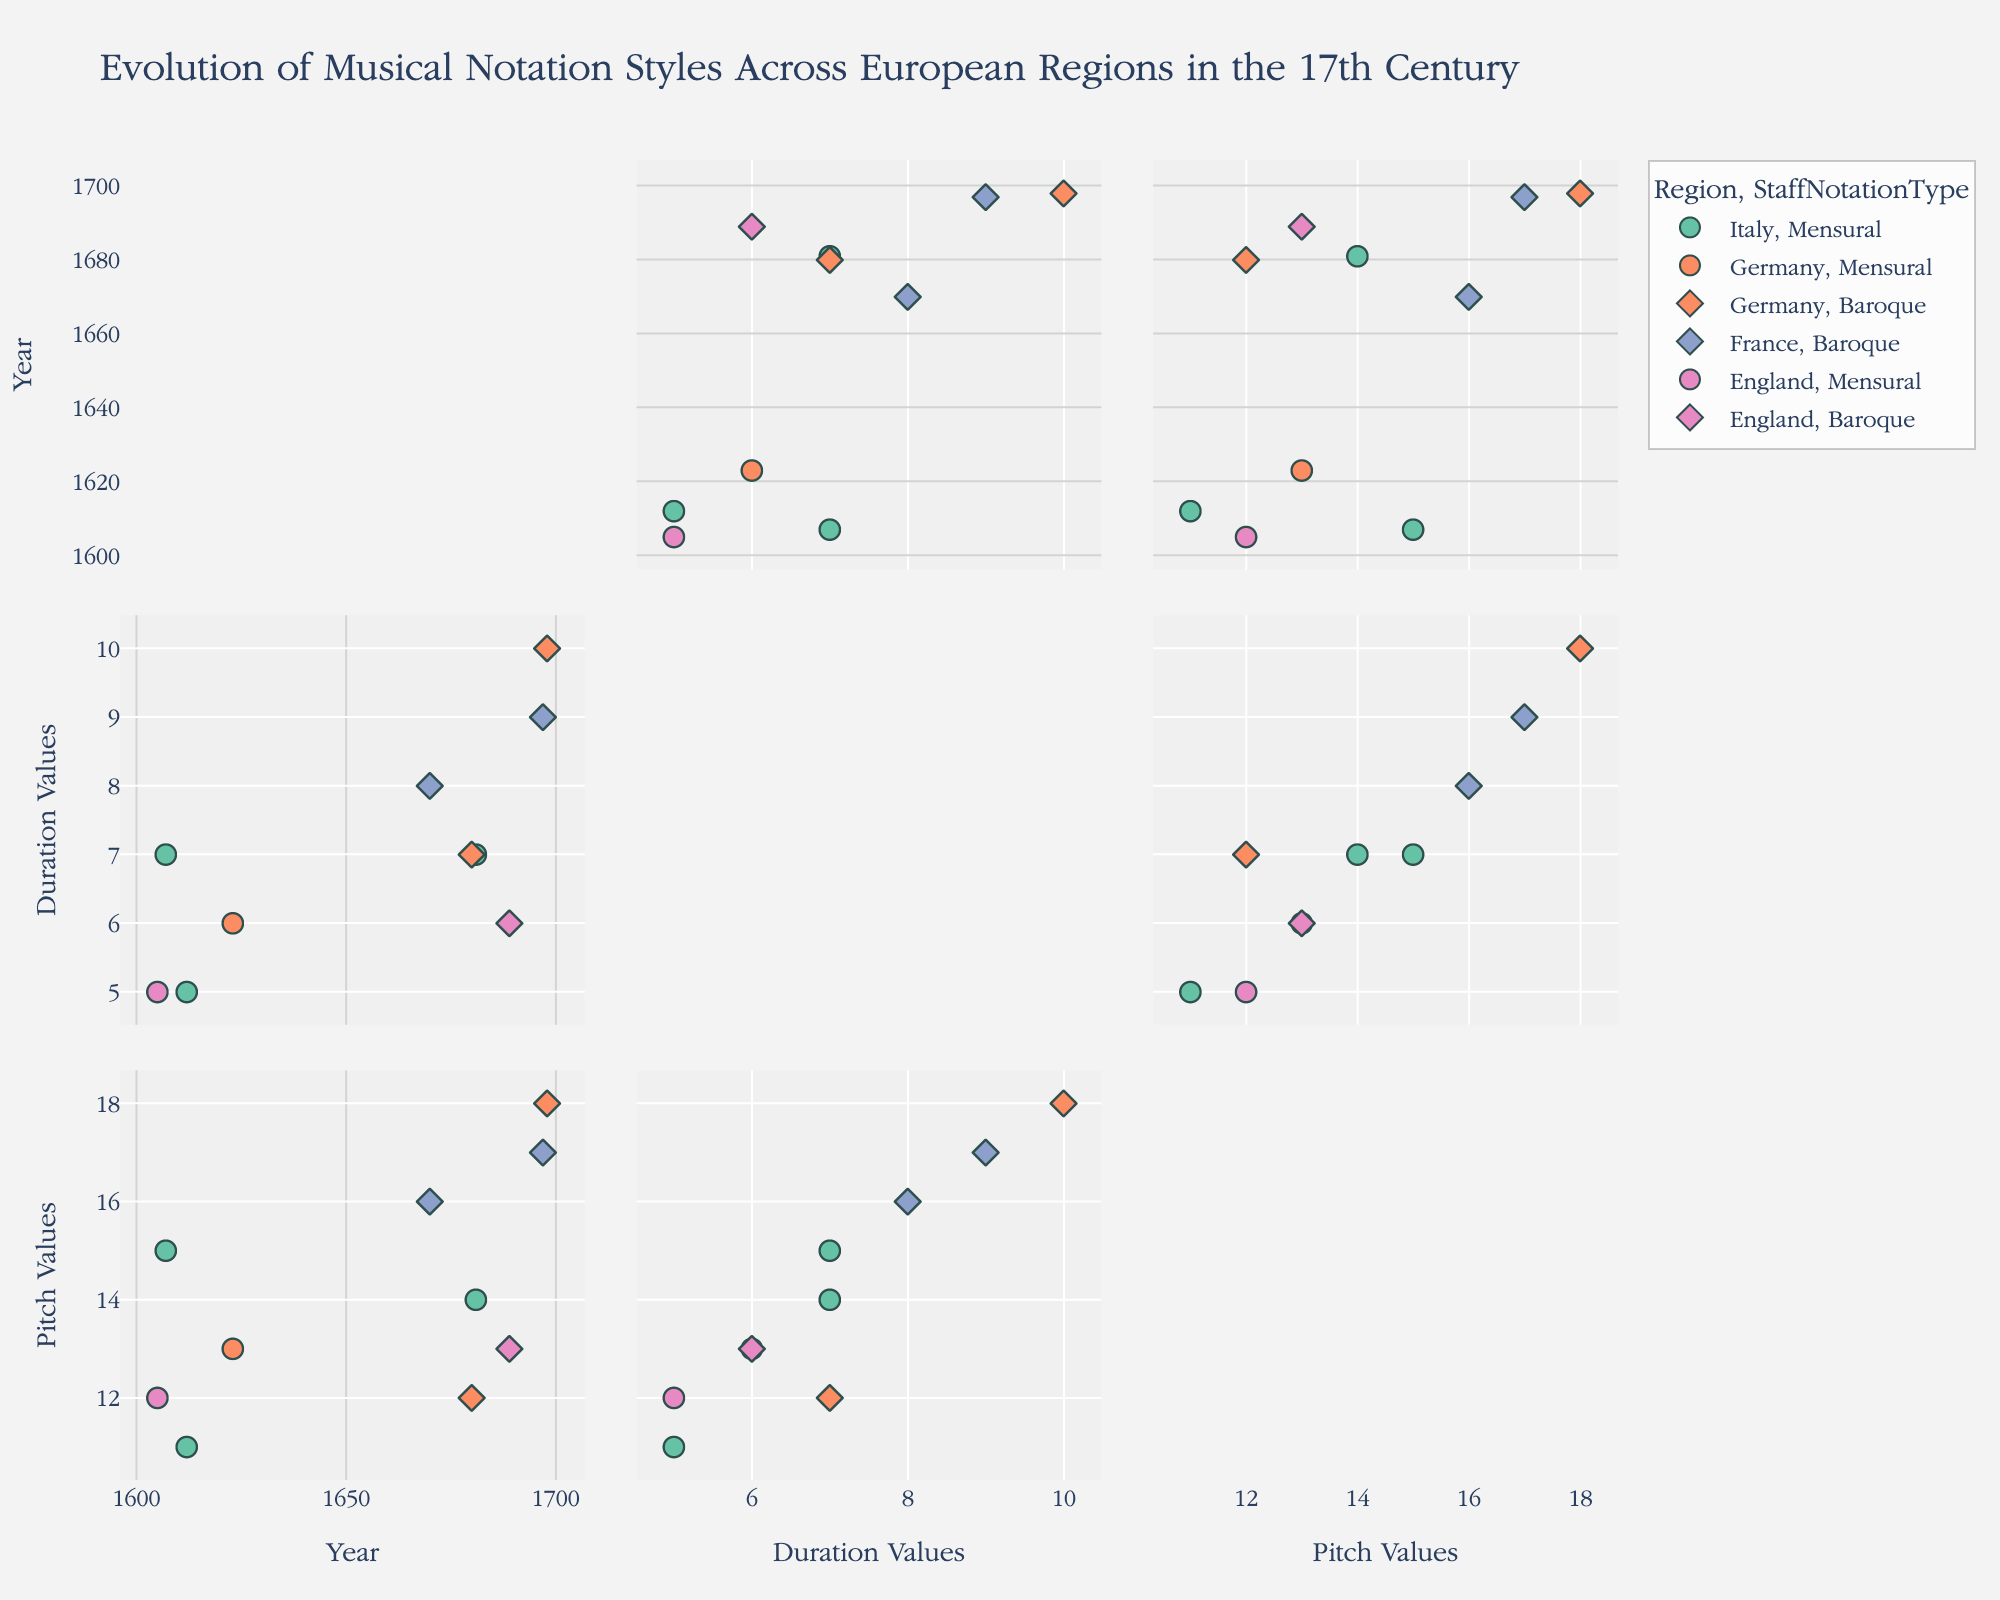What's the title of the figure? The title is usually displayed prominently at the top of the figure. In this case, it should reflect the main subject of the data being visualized.
Answer: Evolution of Musical Notation Styles Across European Regions in the 17th Century How many regions are represented in the SPLOM? By looking at the legend and identifying the unique colors corresponding to different regions, we can count them.
Answer: 4 What staff notation types are used in the data? The notation types can be identified by examining the symbols used in the plot legend. It typically represents categorical variables by different shapes.
Answer: Mensural and Baroque Which composer has the highest Pitch Values and which region are they from? First, locate the highest Pitch Values point on the Pitch Values axis. Hover over the point to see the composer's name and their corresponding region.
Answer: Johann Sebastian Bach, Germany How many data points belong to the 'Baroque' Staff Notation Type? Identify the data points marked with the symbol corresponding to the 'Baroque' Staff Notation Type as shown in the legend and count them.
Answer: 5 Is there a year in which multiple regions are represented? Examine the Year axis and look for overlapping or closely clustered points with different colors, indicating multiple regions. Identify the specific year.
Answer: Yes, there are multiple regions in 1680 Compare the average Duration Values of composers from Germany and Italy. Calculate the mean Duration Values for composers from each region. Germany: (6+10+7)/3 = 7.67; Italy: (7+7+5)/3 = 6.33
Answer: Germany: 7.67, Italy: 6.33 Which region has the most varied Pitch Values? Determine the range of Pitch Values for each region and compare them. A higher range indicates more variation.
Answer: Germany (Range: 18 - 12 = 6) Is there a visible trend in Duration Values over the years for composers from France? Look at the points for France on the Year vs. Duration Values plot and observe if there is any noticeable upward or downward trend over time.
Answer: Yes, an upward trend is visible How do the Pitch Values for Mensural notation compare to Baroque notation? Separate the Pitch Values for each notation type and compare their ranges or typical values. Mensural Pitch Values appear to fluctuate around 15, while Baroque Pitch Values show a higher mean around 16.50
Answer: Baroque has higher Pitch Values overall 